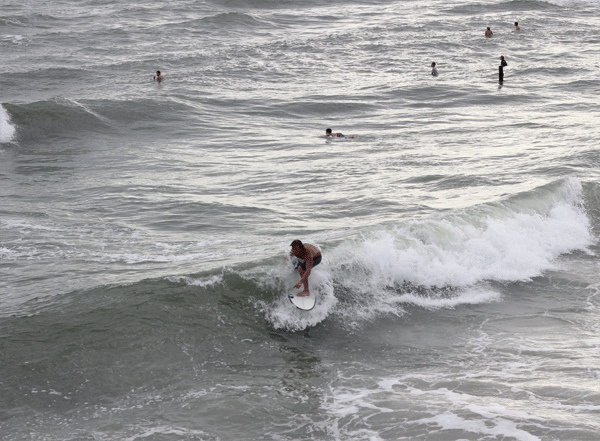Describe the objects in this image and their specific colors. I can see people in darkgray, black, gray, and maroon tones, surfboard in darkgray, lightgray, and gray tones, people in darkgray, gray, and black tones, people in darkgray, black, gray, and lightgray tones, and people in darkgray, gray, and maroon tones in this image. 